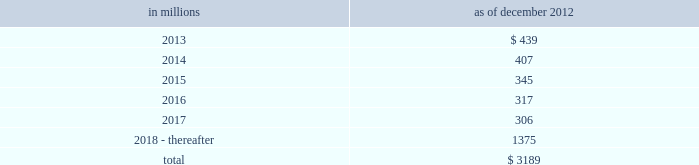Notes to consolidated financial statements sumitomo mitsui financial group , inc .
( smfg ) provides the firm with credit loss protection on certain approved loan commitments ( primarily investment-grade commercial lending commitments ) .
The notional amount of such loan commitments was $ 32.41 billion and $ 31.94 billion as of december 2012 and december 2011 , respectively .
The credit loss protection on loan commitments provided by smfg is generally limited to 95% ( 95 % ) of the first loss the firm realizes on such commitments , up to a maximum of approximately $ 950 million .
In addition , subject to the satisfaction of certain conditions , upon the firm 2019s request , smfg will provide protection for 70% ( 70 % ) of additional losses on such commitments , up to a maximum of $ 1.13 billion , of which $ 300 million of protection had been provided as of both december 2012 and december 2011 .
The firm also uses other financial instruments to mitigate credit risks related to certain commitments not covered by smfg .
These instruments primarily include credit default swaps that reference the same or similar underlying instrument or entity or credit default swaps that reference a market index .
Warehouse financing .
The firm provides financing to clients who warehouse financial assets .
These arrangements are secured by the warehoused assets , primarily consisting of commercial mortgage loans .
Contingent and forward starting resale and securities borrowing agreements/forward starting repurchase and secured lending agreements the firm enters into resale and securities borrowing agreements and repurchase and secured lending agreements that settle at a future date .
The firm also enters into commitments to provide contingent financing to its clients and counterparties through resale agreements .
The firm 2019s funding of these commitments depends on the satisfaction of all contractual conditions to the resale agreement and these commitments can expire unused .
Investment commitments the firm 2019s investment commitments consist of commitments to invest in private equity , real estate and other assets directly and through funds that the firm raises and manages .
These commitments include $ 872 million and $ 1.62 billion as of december 2012 and december 2011 , respectively , related to real estate private investments and $ 6.47 billion and $ 7.50 billion as of december 2012 and december 2011 , respectively , related to corporate and other private investments .
Of these amounts , $ 6.21 billion and $ 8.38 billion as of december 2012 and december 2011 , respectively , relate to commitments to invest in funds managed by the firm , which will be funded at market value on the date of investment .
Leases the firm has contractual obligations under long-term noncancelable lease agreements , principally for office space , expiring on various dates through 2069 .
Certain agreements are subject to periodic escalation provisions for increases in real estate taxes and other charges .
The table below presents future minimum rental payments , net of minimum sublease rentals .
In millions december 2012 .
Rent charged to operating expense for the years ended december 2012 , december 2011 and december 2010 was $ 374 million , $ 475 million and $ 508 million , respectively .
Operating leases include office space held in excess of current requirements .
Rent expense relating to space held for growth is included in 201coccupancy . 201d the firm records a liability , based on the fair value of the remaining lease rentals reduced by any potential or existing sublease rentals , for leases where the firm has ceased using the space and management has concluded that the firm will not derive any future economic benefits .
Costs to terminate a lease before the end of its term are recognized and measured at fair value on termination .
Goldman sachs 2012 annual report 175 .
What percentage of future minimum rental payments is due after 2017? 
Computations: (1375 / 3189)
Answer: 0.43117. 